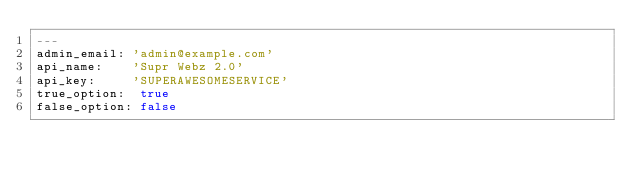<code> <loc_0><loc_0><loc_500><loc_500><_YAML_>---
admin_email: 'admin@example.com'
api_name:    'Supr Webz 2.0'
api_key:     'SUPERAWESOMESERVICE'
true_option:  true
false_option: false
</code> 